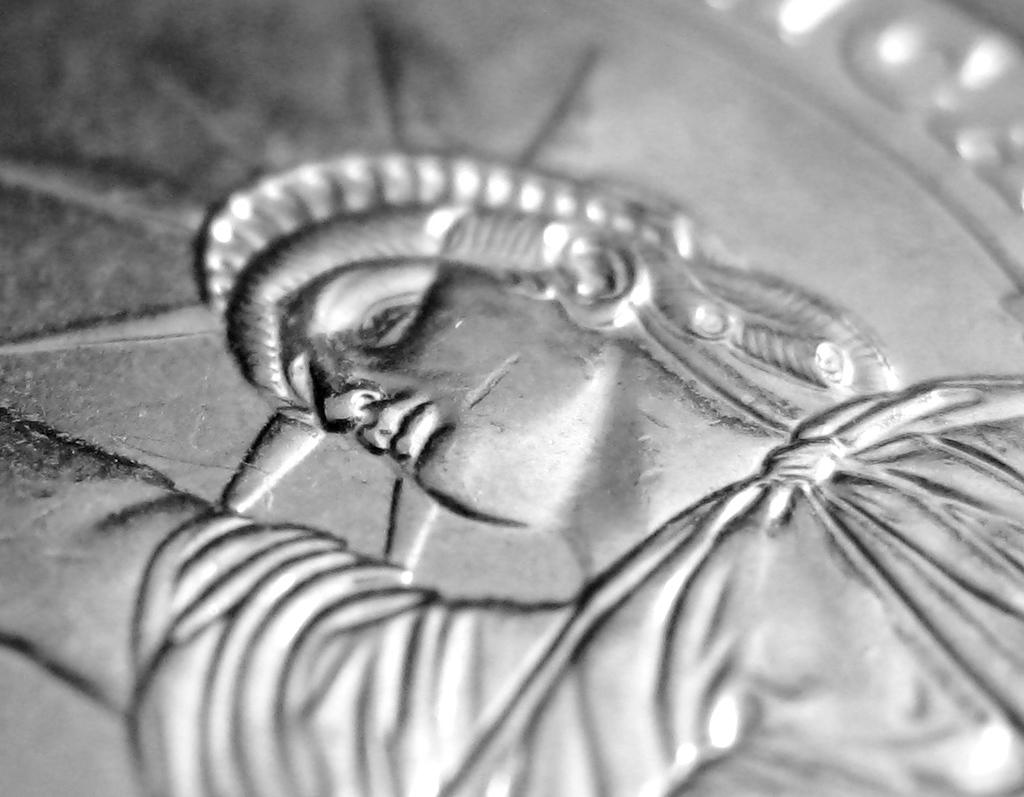What is the main subject of the image? The main subject of the image is a statue of liberty. What is the statue of liberty placed on? The statue of liberty is on a metal object. How many eggs are visible in the image? There are no eggs present in the image. What type of tramp is sitting near the statue of liberty in the image? There is no tramp present in the image. 